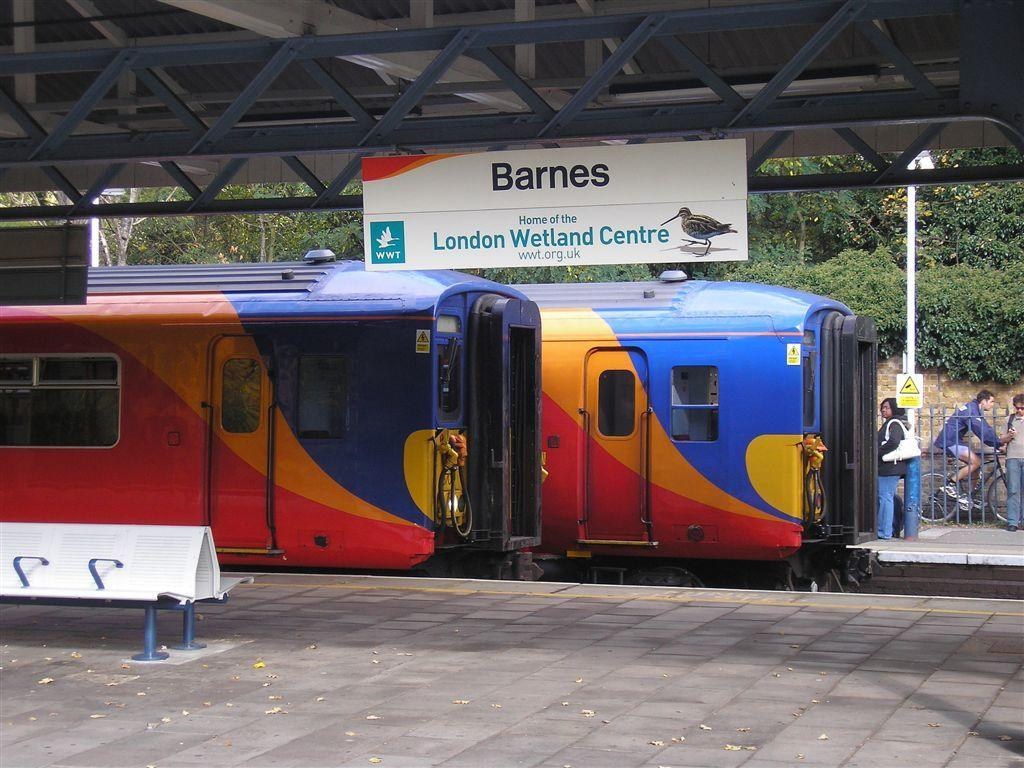<image>
Present a compact description of the photo's key features. A yellow, red and blue train underneath a sign with the word Barnes on it. 